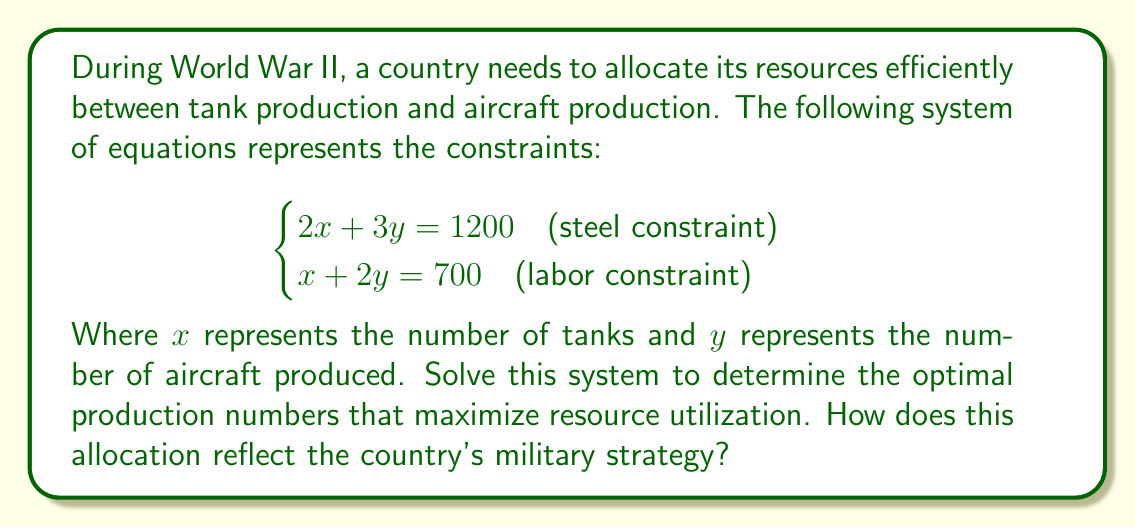Help me with this question. To solve this system of linear equations, we'll use the substitution method:

1) From the second equation, express $x$ in terms of $y$:
   $x + 2y = 700$
   $x = 700 - 2y$

2) Substitute this expression for $x$ into the first equation:
   $2(700 - 2y) + 3y = 1200$
   $1400 - 4y + 3y = 1200$
   $1400 - y = 1200$

3) Solve for $y$:
   $-y = -200$
   $y = 200$

4) Substitute $y = 200$ back into the equation for $x$:
   $x = 700 - 2(200) = 300$

Therefore, the optimal production is 300 tanks and 200 aircraft.

This allocation reflects a balanced approach to military strategy, emphasizing both ground and air capabilities. The higher number of tanks suggests a focus on land warfare, possibly indicating preparation for large-scale ground operations. The significant number of aircraft shows recognition of the growing importance of air power in modern warfare.

This balance aligns with the historical context of World War II, where both tanks and aircraft played crucial roles in major operations. The allocation demonstrates the country's attempt to maintain a versatile and adaptable military force, capable of engaging in various types of combat scenarios.
Answer: 300 tanks, 200 aircraft 